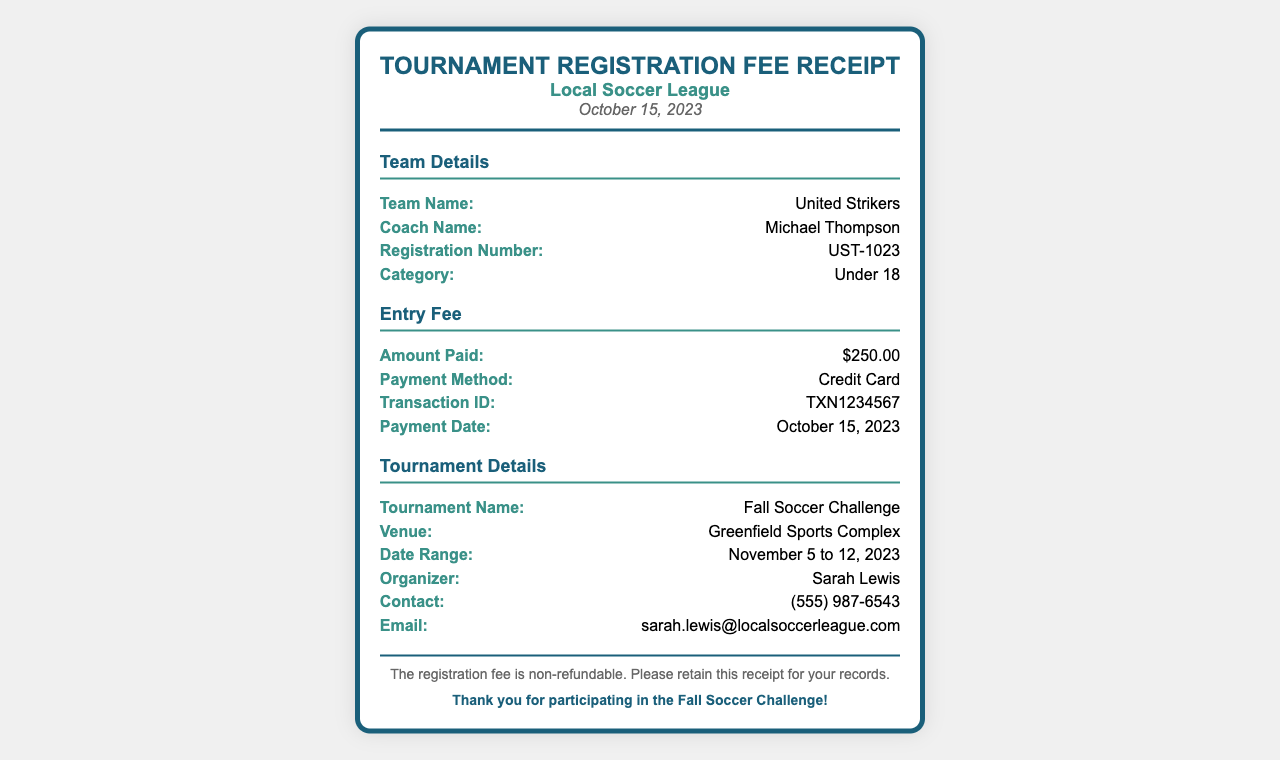what is the team name? The team name is specified in the document, and it is provided under "Team Details."
Answer: United Strikers who is the coach? The coach's name is listed in the "Team Details" section of the document.
Answer: Michael Thompson what is the registration number? The registration number can be found in the "Team Details" section of the document.
Answer: UST-1023 how much was the entry fee? The entry fee amount is detailed in the "Entry Fee" section of the document.
Answer: $250.00 what method was used for payment? The payment method is indicated in the "Entry Fee" section of the document.
Answer: Credit Card what is the venue for the tournament? The venue is provided in the "Tournament Details" section of the document.
Answer: Greenfield Sports Complex who is the organizer of the tournament? The organizer's name is found in the "Tournament Details" section of the document.
Answer: Sarah Lewis when was the payment date? The payment date is specified in the "Entry Fee" section of the document.
Answer: October 15, 2023 what is the tournament name? The tournament name is listed in the "Tournament Details" section of the document.
Answer: Fall Soccer Challenge 